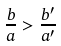<formula> <loc_0><loc_0><loc_500><loc_500>\frac { b } { a } > \frac { b ^ { \prime } } { a ^ { \prime } }</formula> 